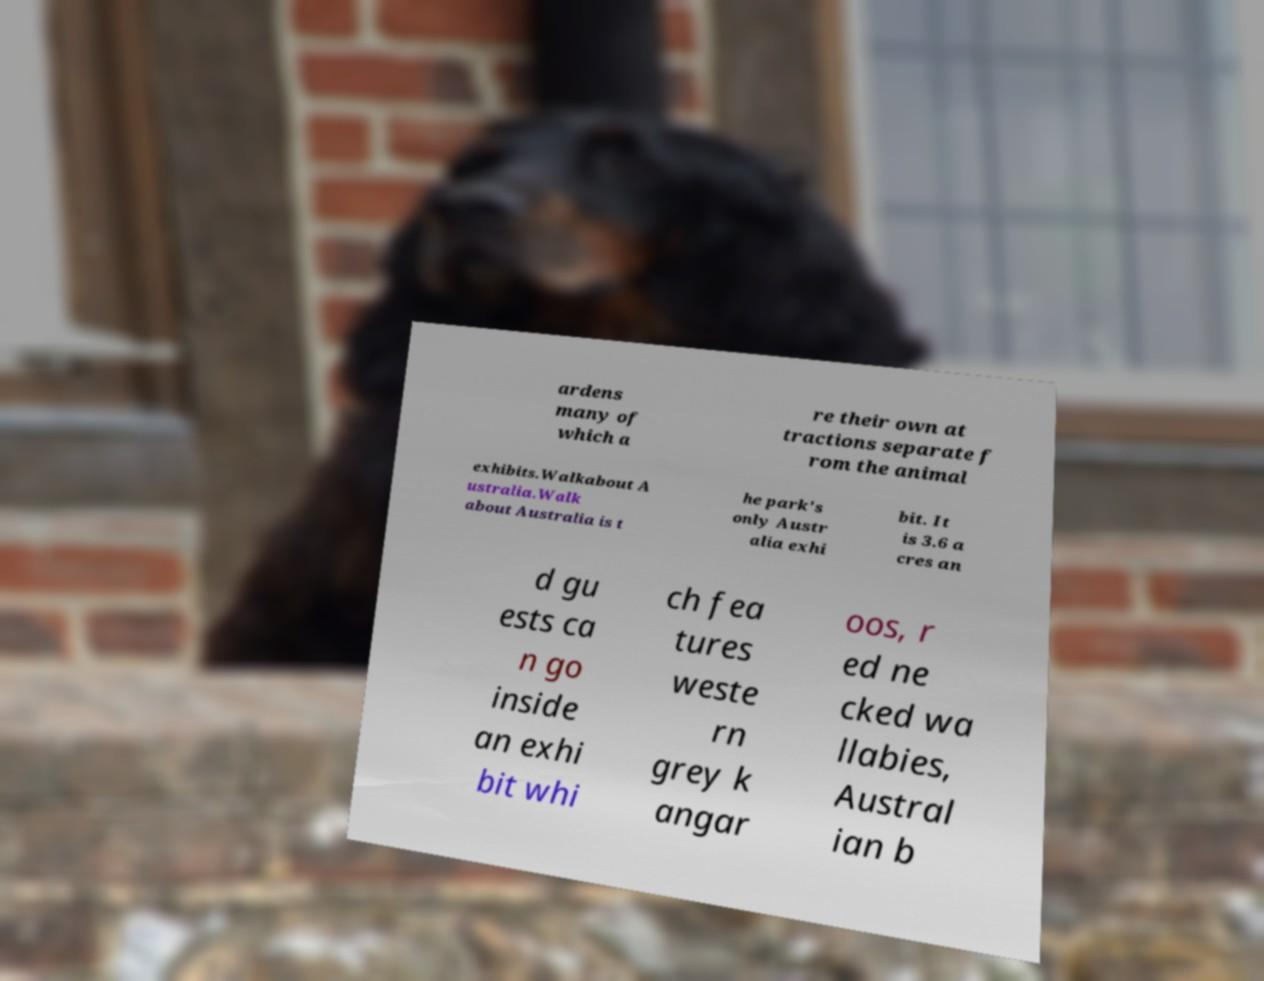Please read and relay the text visible in this image. What does it say? ardens many of which a re their own at tractions separate f rom the animal exhibits.Walkabout A ustralia.Walk about Australia is t he park's only Austr alia exhi bit. It is 3.6 a cres an d gu ests ca n go inside an exhi bit whi ch fea tures weste rn grey k angar oos, r ed ne cked wa llabies, Austral ian b 